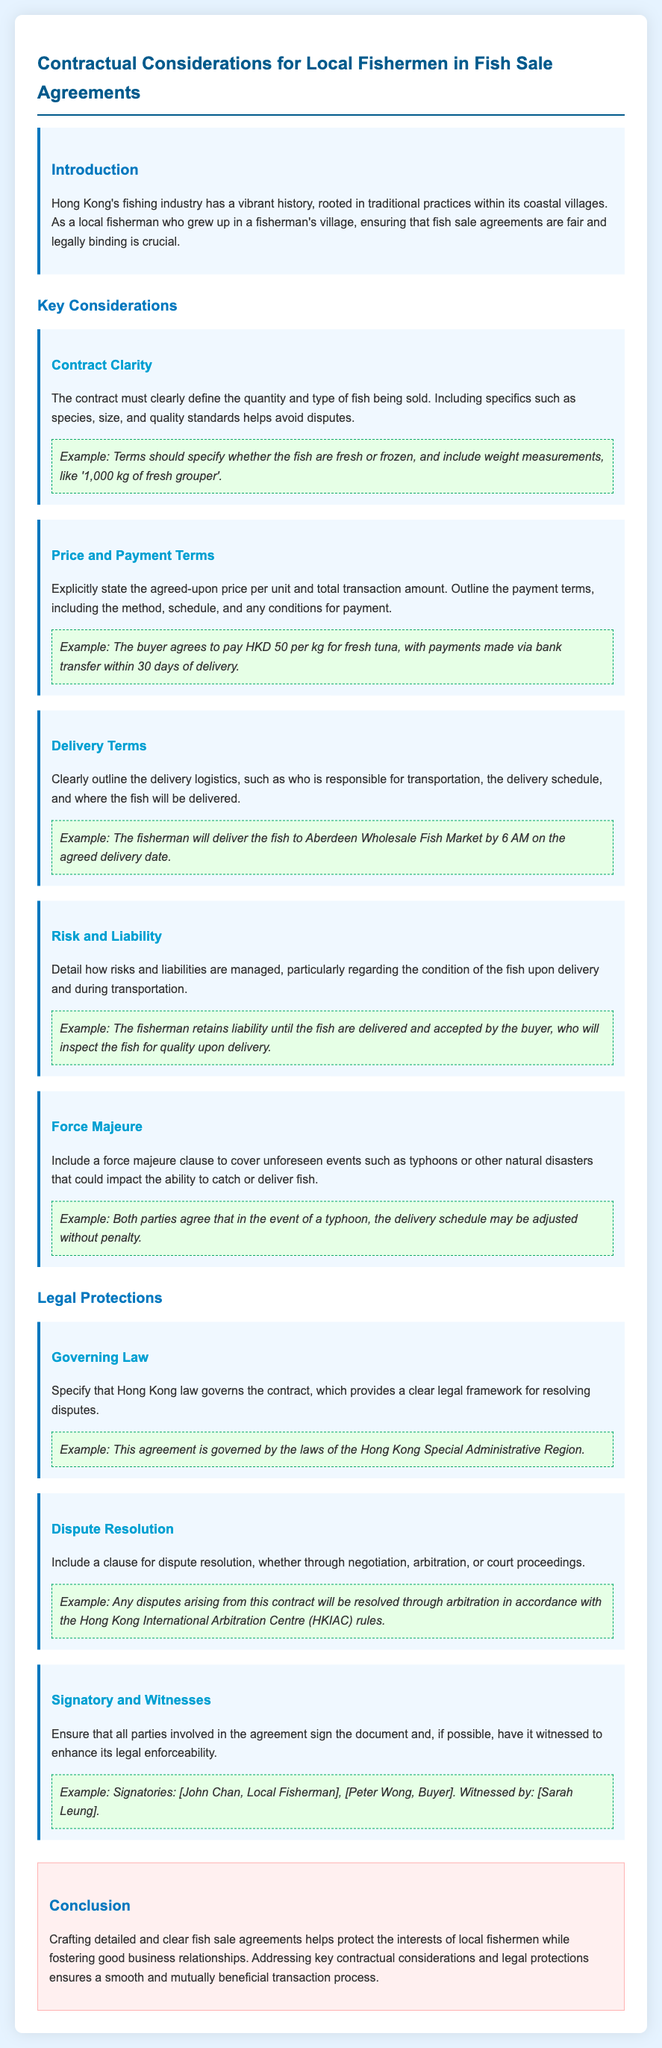What is the title of the document? The title is indicated at the top of the document, summarizing its main focus.
Answer: Contractual Considerations for Local Fishermen in Fish Sale Agreements What is specified in the contract regarding the fish? The document highlights the need for clarity in defining specifics about the fish, including essential details.
Answer: Quantity and type How much is the price per kilogram for fresh tuna? The document provides the specific agreed-upon price during the payment terms section.
Answer: HKD 50 What should be included in the delivery terms? The delivery terms section outlines logistics regarding fish transportation and delivery details.
Answer: Delivery logistics Which law governs the agreement? The legal framework for the contract is stated, specifying the jurisdiction for any disputes.
Answer: Hong Kong law What is recommended for dispute resolution? The document suggests methods for resolving potential conflicts arising from the contract.
Answer: Arbitration What risk does the fisherman retain until delivery? The liability for the condition of the fish is highlighted in the document under risk management.
Answer: Until the fish are delivered What type of clause should cover natural disasters? The document suggests including a specific clause to address unforeseen events that may impact the contract.
Answer: Force majeure Who should sign the agreement? The document specifies who should be included as signatories to enhance legal enforceability.
Answer: All parties involved 